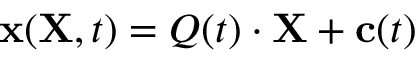<formula> <loc_0><loc_0><loc_500><loc_500>x ( X , t ) = { Q } ( t ) \cdot X + c ( t )</formula> 